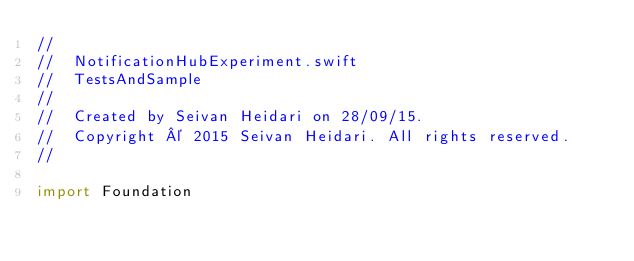<code> <loc_0><loc_0><loc_500><loc_500><_Swift_>//
//  NotificationHubExperiment.swift
//  TestsAndSample
//
//  Created by Seivan Heidari on 28/09/15.
//  Copyright © 2015 Seivan Heidari. All rights reserved.
//

import Foundation
</code> 